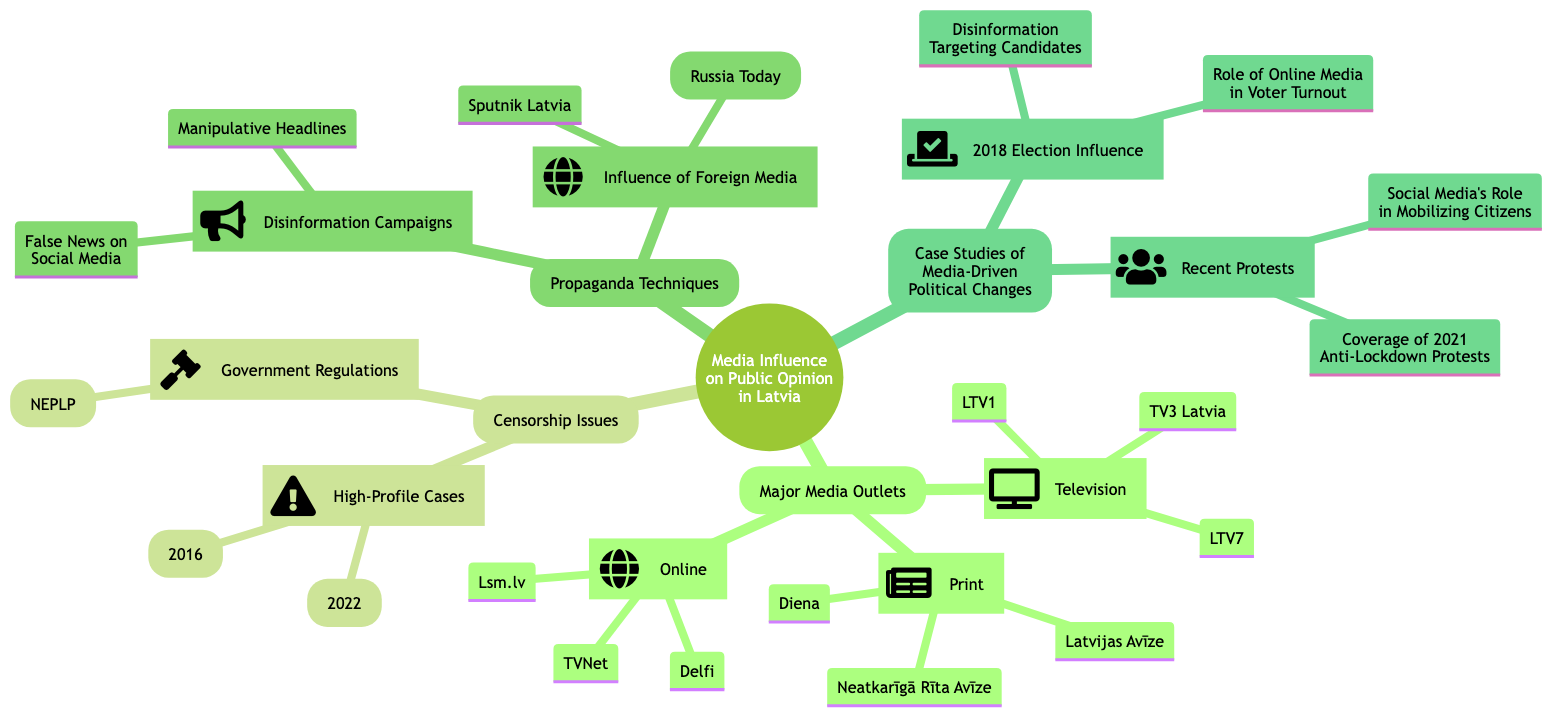What are the major television media outlets in Latvia? The diagram indicates that the major television media outlets in Latvia include LTV1, LTV7, and TV3 Latvia, all listed under the "Television" category in the "Major Media Outlets" section.
Answer: LTV1, LTV7, TV3 Latvia How many print media outlets are mentioned in the diagram? In the "Print" category under the "Major Media Outlets," there are three entries listed: Diena, Latvijas Avīze, and Neatkarīgā Rīta Avīze, which totals to three print media outlets.
Answer: 3 What organization oversees government regulations related to media in Latvia? The diagram specifies that the National Electronic Mass Media Council (NEPLP) is responsible for government regulations, categorized under "Censorship Issues" and listed under "Government Regulations."
Answer: National Electronic Mass Media Council (NEPLP) What is a highlighted case of censorship from 2016? The diagram illustrates that one notable case of censorship in 2016 was the "Shutting down of Baltkom Radio," which is explicitly cited under "High-Profile Cases" in the "Censorship Issues" section.
Answer: Shutting down of Baltkom Radio Identify one disinformation campaign technique mentioned in the diagram. The diagram includes "False News on Social Media" as one of the disinformation campaign techniques listed under "Disinformation Campaigns" in the "Propaganda Techniques" section.
Answer: False News on Social Media How did social media influence protests in 2021 according to the diagram? The diagram states that social media played a significant role in mobilizing citizens during the protests in 2021, which is summarized in the "Recent Protests" section under "Case Studies of Media-Driven Political Changes."
Answer: Social Media's Role in Mobilizing Citizens What was one of the influences on the 2018 Election? The diagram indicates that "Disinformation Targeting Candidates" is one of the influences noted for the 2018 election, found under the "2018 Election Influence" subsection in "Case Studies of Media-Driven Political Changes."
Answer: Disinformation Targeting Candidates Which foreign media outlet is listed in the propaganda techniques? The diagram lists "RT (Russia Today)" as one of the foreign media outlets under "Influence of Foreign Media" in the "Propaganda Techniques" section.
Answer: RT (Russia Today) 